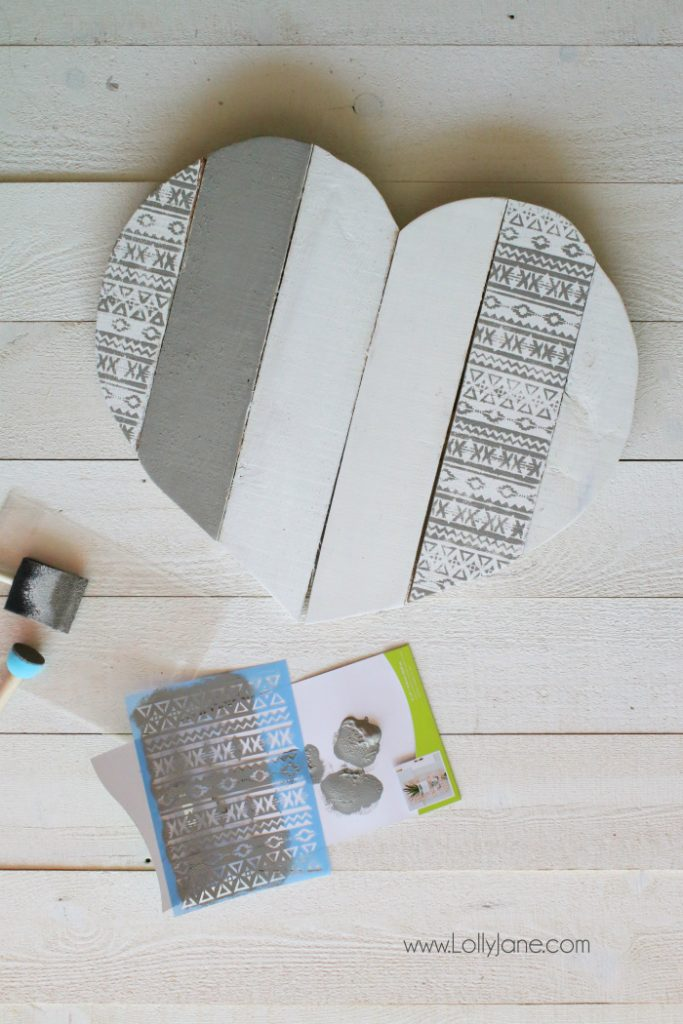What does the pattern on the stencil suggest about the artistic style of the creator? The pattern on the stencil suggests that the creator has an appreciation for geometric and intricate designs, reflecting an artistic style that values symmetry, precision, and a touch of modernity. The repetitive nature of the pattern hints at influences from traditional crafts, possibly Scandinavian or ethnic designs, combined with a contemporary aesthetic. Why might the creator have chosen a heart shape for their artwork? The heart shape is universally recognized as a symbol of love and affection. By choosing a heart shape, the creator may have wanted to evoke feelings of warmth, care, and emotional connection. This symbolic shape makes the artwork suitable for gifts, home decor items, or special occasions such as Valentine's Day, anniversaries, and weddings. The combination of the heart shape and the elegant, patterned design creates a piece that is both visually appealing and emotionally resonant. Imagine this heart was part of a larger collection. What other shapes and designs might be included, and for what occasions could these be used? If this heart were part of a larger collection, other shapes could include stars, circles, and perhaps hexagons, each adorned with similar patterned designs. Stars might symbolize excellence and inspiration, making them ideal for congratulatory gifts or awards. Circles could represent unity, eternity, and wholeness, perfect for weddings, anniversaries, and family gatherings. Hexagons, with their natural association to bees and honeycombs, could signify industry, teamwork, and the sweet rewards of hard work, suited for professional achievements or work-related milestones. Each piece, like the heart, would be imbued with thoughtful design and symbolic meaning, making them versatile for a range of celebratory or decorative purposes. Consider that the creator plans to expand their craft into functional home decor items. What items could they design, and how might they incorporate the geometric patterns into these pieces? Expanding into functional home decor, the creator could design a variety of items such as picture frames, coasters, wall shelves, small storage boxes, and even furniture like side tables and chairs. They could incorporate the geometric patterns by using stencils or engraving tools to decorate the surfaces of these items. For instance, picture frames could have patterned borders, coasters could feature intricate designs on their tops, and wall shelves could have patterned backs or sides. For furniture, the creator could integrate the patterns into the table tops or the backs of chairs, creating unique, stylish pieces that are both practical and aesthetically pleasing. The geometric patterns would add a cohesive and artistic touch, making each item stand out while maintaining a unified design theme throughout their collection. 